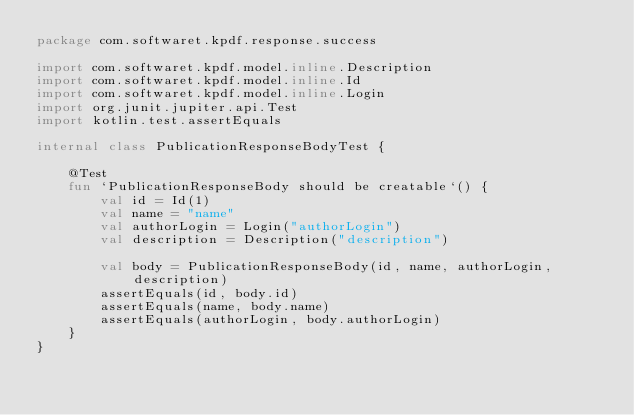<code> <loc_0><loc_0><loc_500><loc_500><_Kotlin_>package com.softwaret.kpdf.response.success

import com.softwaret.kpdf.model.inline.Description
import com.softwaret.kpdf.model.inline.Id
import com.softwaret.kpdf.model.inline.Login
import org.junit.jupiter.api.Test
import kotlin.test.assertEquals

internal class PublicationResponseBodyTest {

    @Test
    fun `PublicationResponseBody should be creatable`() {
        val id = Id(1)
        val name = "name"
        val authorLogin = Login("authorLogin")
        val description = Description("description")

        val body = PublicationResponseBody(id, name, authorLogin, description)
        assertEquals(id, body.id)
        assertEquals(name, body.name)
        assertEquals(authorLogin, body.authorLogin)
    }
}
</code> 